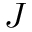Convert formula to latex. <formula><loc_0><loc_0><loc_500><loc_500>J</formula> 